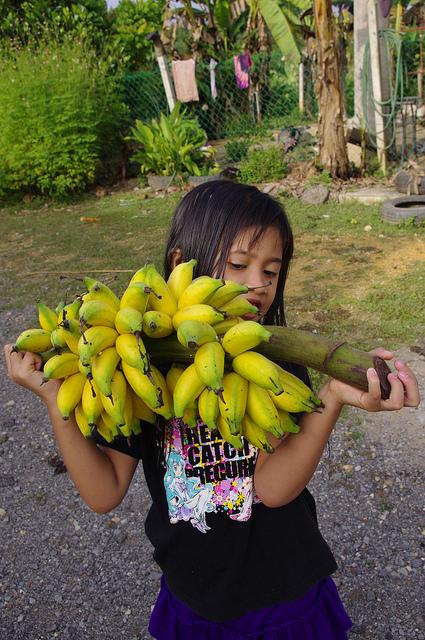Is the child smiling?
Quick response, please. No. Would it be wise to hold off on peeling these edibles?
Short answer required. Yes. What fruit is the child holding?
Keep it brief. Bananas. Is the child female or male?
Be succinct. Female. 